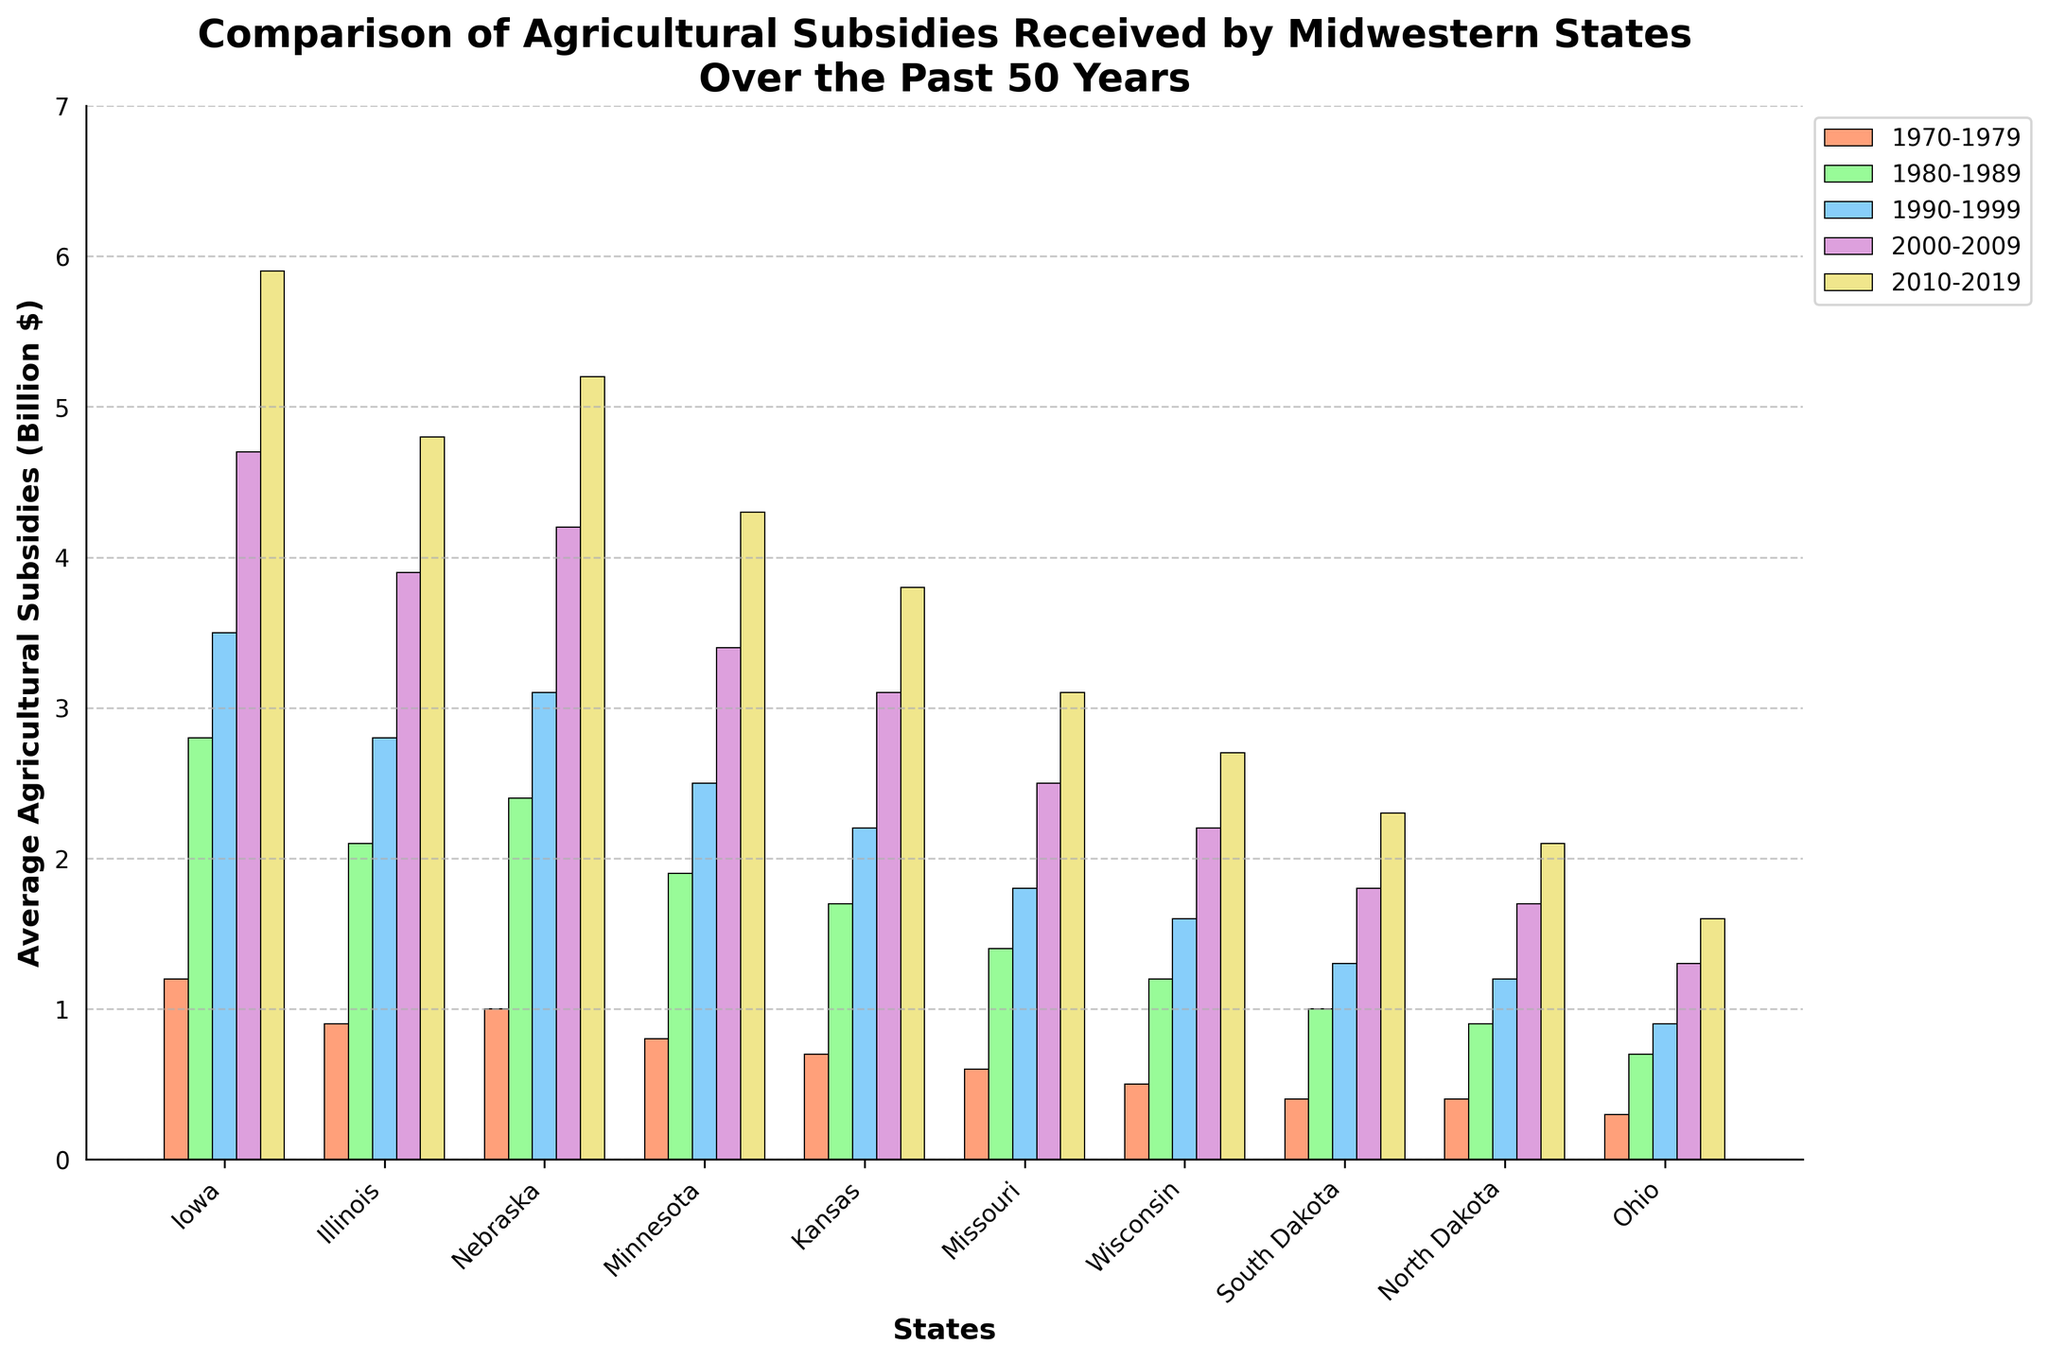Which state received the highest average agricultural subsidy in the 2010-2019 period? Identify the tallest bar among the states for the 2010-2019 period, which is labeled with the year and specific color. Iowa's bar is the highest.
Answer: Iowa Which state shows the smallest increase in average agricultural subsidies from the 1970-1979 period to the 2010-2019 period? Calculate the difference between 2010-2019 and 1970-1979 averages for all states. The smallest difference is observed in Ohio (1.6 - 0.3 = 1.3).
Answer: Ohio What is the average subsidy in 2000-2009 for Illinois and Nebraska combined? Add the values for Illinois and Nebraska in 2000-2009 and divide by 2. (3.9 + 4.2) / 2 = 4.05
Answer: 4.05 Which state saw the largest increase in subsidies between 1980-1989 and 1990-1999? Calculate the difference in subsidies between 1990-1999 and 1980-1989 for each state, and find the maximum. Iowa's increase is the largest (3.5 - 2.8 = 0.7).
Answer: Iowa Was the average agricultural subsidy for Wisconsin ever higher than 2.5 billion dollars? Check the bar heights for Wisconsin in all periods and compare them with 2.5. Wisconsin's highest value is 2.7 in 2010-2019.
Answer: Yes Among Iowa, Wisconsin, and Ohio, which state had the lowest average subsidy in 1990-1999? Compare the bar heights for Iowa, Wisconsin, and Ohio in the 1990-1999 period. Ohio has the lowest value at 0.9.
Answer: Ohio By how much did Minnesota's average subsidy increase from the 1970-1979 period to the 2010-2019 period? Calculate the difference between Minnesota's values in 2010-2019 and 1970-1979. 4.3 - 0.8 = 3.5
Answer: 3.5 Which state had greater subsidies in 1980-1989, Missouri or Wisconsin? Compare the bar heights for Missouri and Wisconsin in the 1980-1989 period. Missouri's value (1.4) is greater than Wisconsin's (1.2).
Answer: Missouri What's the total subsidy received by North Dakota and Ohio combined in the period from 2000 to 2009? Add the values of North Dakota and Ohio in the 2000-2009 period. 1.7 + 1.3 = 3.0
Answer: 3.0 